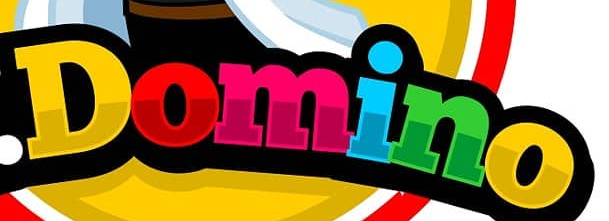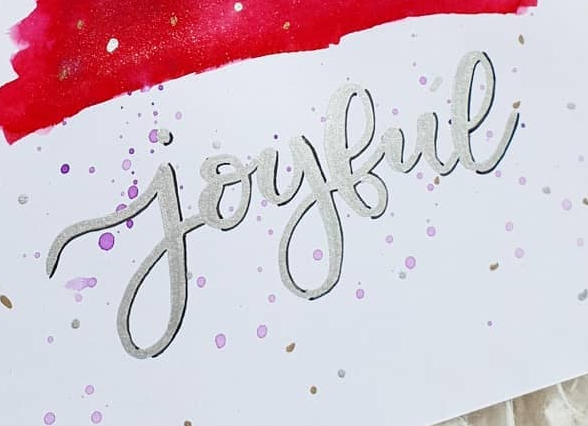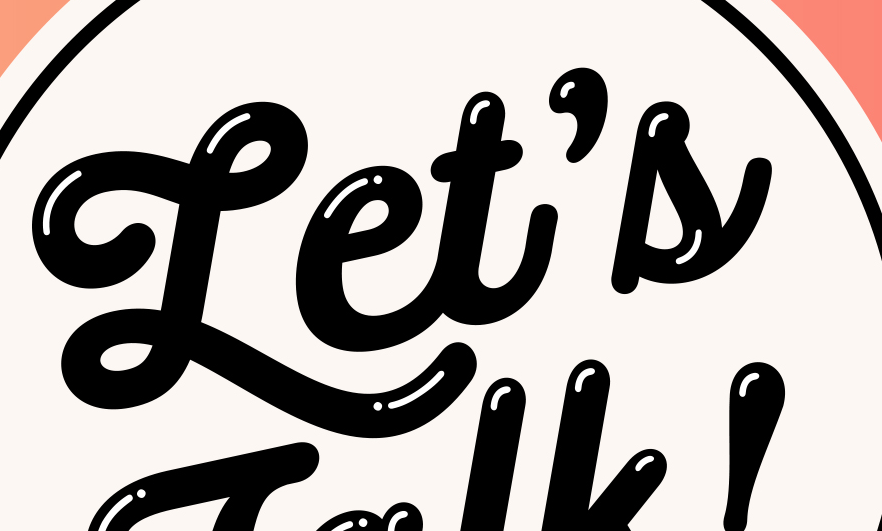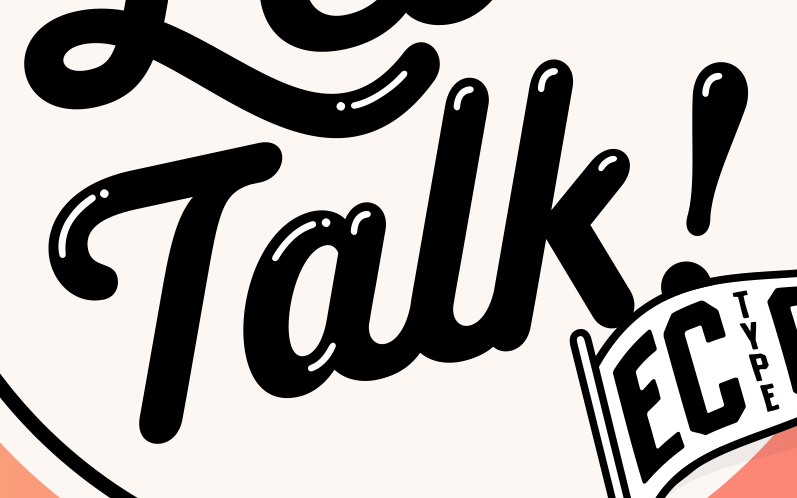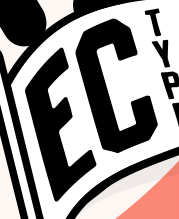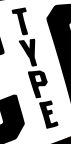Read the text from these images in sequence, separated by a semicolon. Domino; joybue; Let's; Talk!; EC; TYPE 